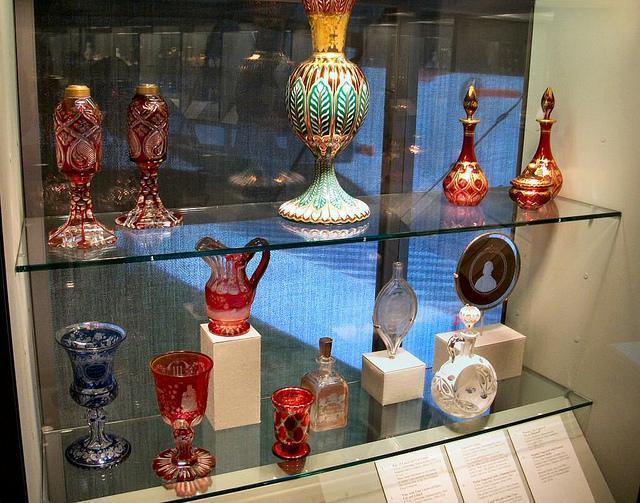How many bottles are visible?
Give a very brief answer. 3. How many wine glasses are there?
Give a very brief answer. 2. How many vases are there?
Give a very brief answer. 2. 